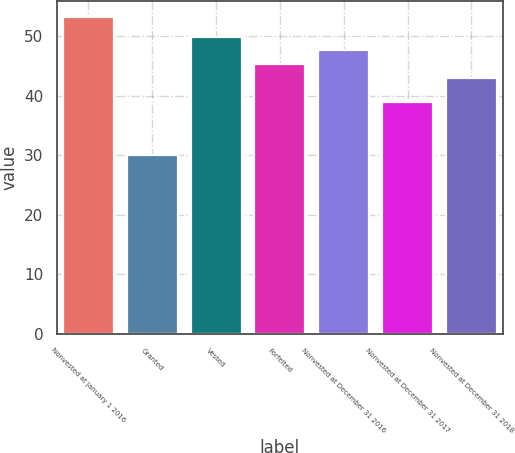Convert chart. <chart><loc_0><loc_0><loc_500><loc_500><bar_chart><fcel>Nonvested at January 1 2016<fcel>Granted<fcel>Vested<fcel>Forfeited<fcel>Nonvested at December 31 2016<fcel>Nonvested at December 31 2017<fcel>Nonvested at December 31 2018<nl><fcel>53.18<fcel>30.07<fcel>49.9<fcel>45.28<fcel>47.59<fcel>38.86<fcel>42.97<nl></chart> 